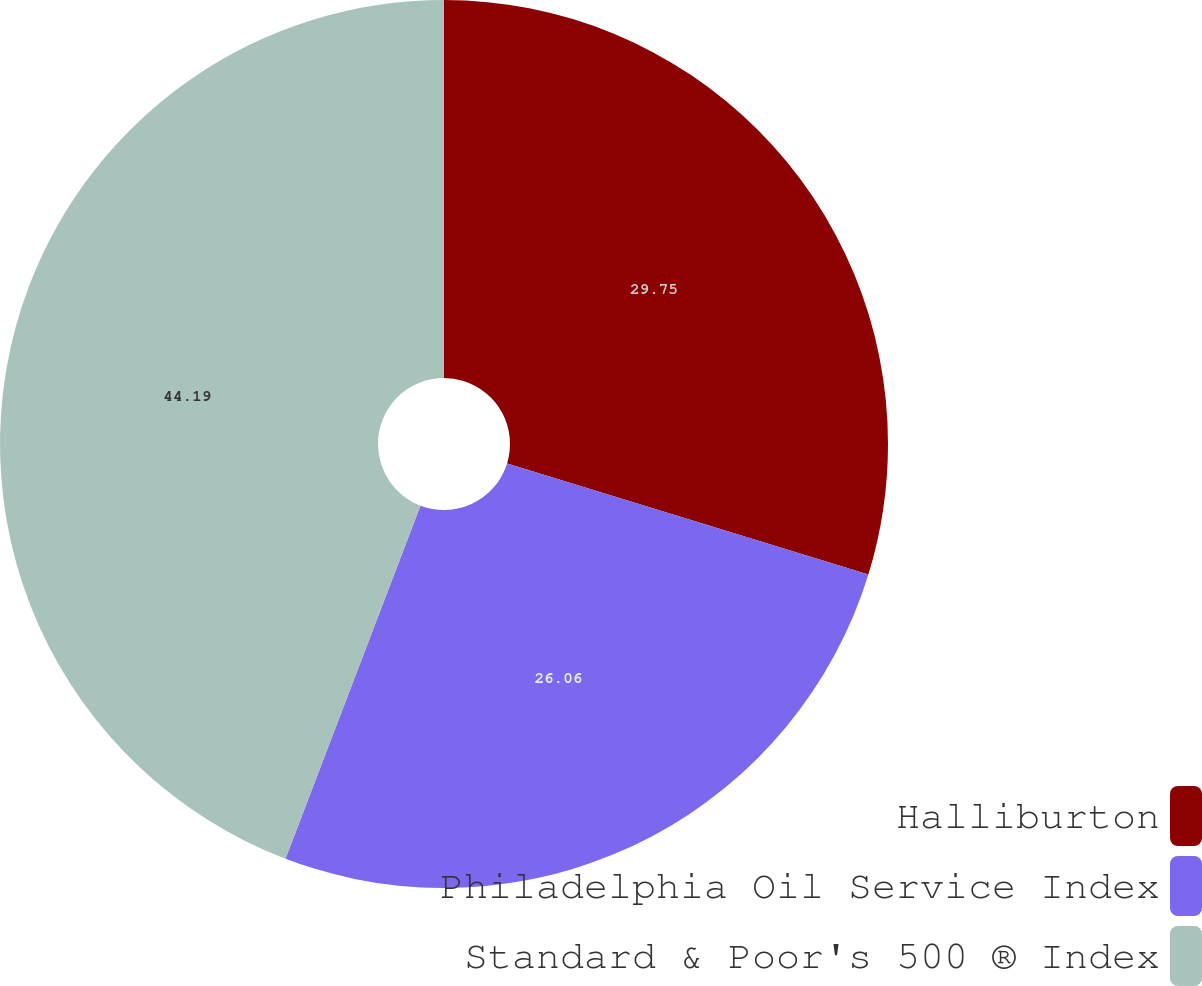Convert chart to OTSL. <chart><loc_0><loc_0><loc_500><loc_500><pie_chart><fcel>Halliburton<fcel>Philadelphia Oil Service Index<fcel>Standard & Poor's 500 ® Index<nl><fcel>29.75%<fcel>26.06%<fcel>44.19%<nl></chart> 